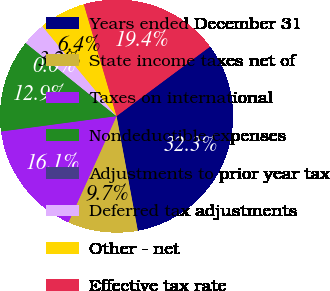<chart> <loc_0><loc_0><loc_500><loc_500><pie_chart><fcel>Years ended December 31<fcel>State income taxes net of<fcel>Taxes on international<fcel>Nondeductible expenses<fcel>Adjustments to prior year tax<fcel>Deferred tax adjustments<fcel>Other - net<fcel>Effective tax rate<nl><fcel>32.26%<fcel>9.68%<fcel>16.13%<fcel>12.9%<fcel>0.0%<fcel>3.23%<fcel>6.45%<fcel>19.35%<nl></chart> 